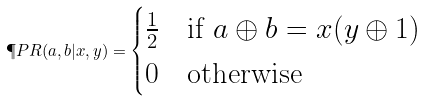Convert formula to latex. <formula><loc_0><loc_0><loc_500><loc_500>\P P R ( a , b | x , y ) = \begin{cases} \frac { 1 } { 2 } & \text {if $ a \oplus b = x(y \oplus 1)$} \\ 0 & \text {otherwise} \end{cases}</formula> 